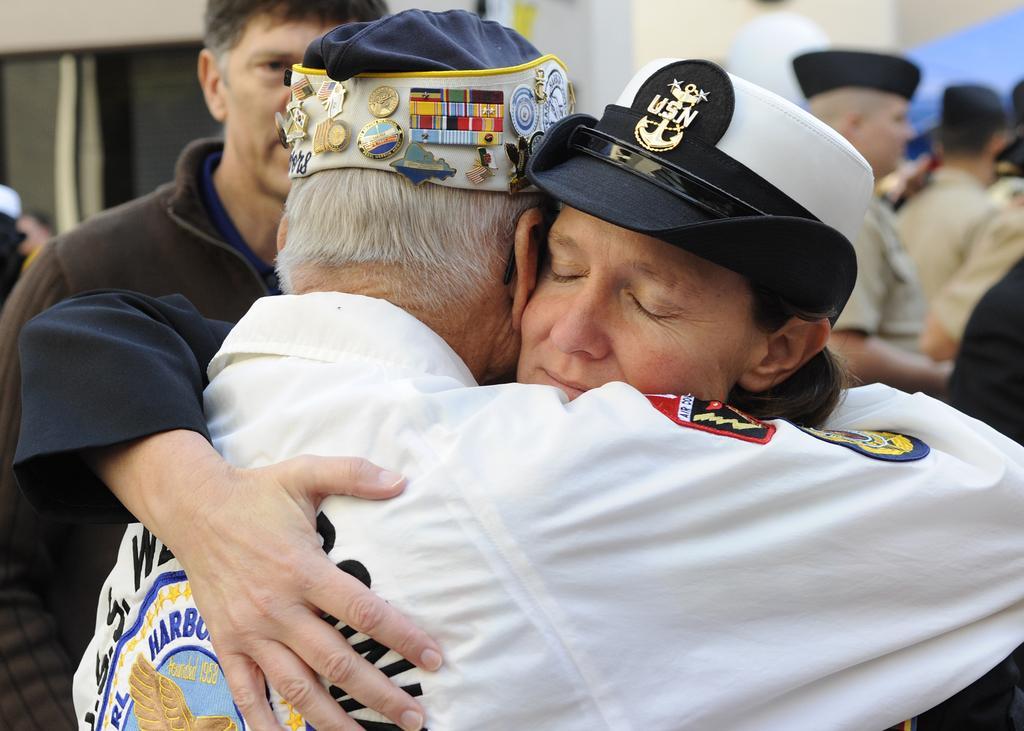Please provide a concise description of this image. In the image we can see there are people standing and they are wearing caps. There are badges on the cap. 